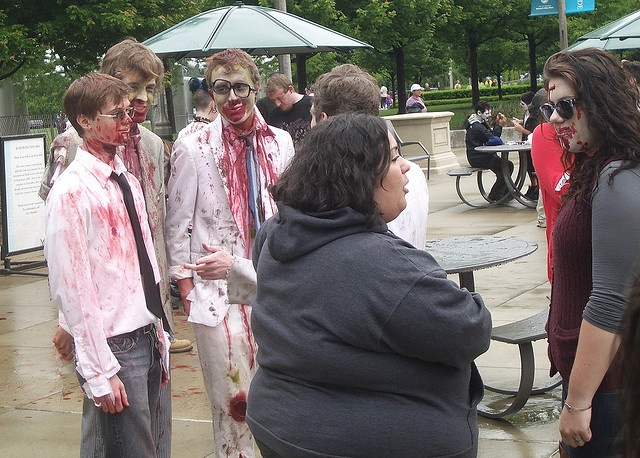Describe the objects in this image and their specific colors. I can see people in black and gray tones, people in black, gray, and maroon tones, people in black, lavender, gray, and brown tones, people in black, lavender, darkgray, brown, and pink tones, and people in black, gray, and darkgray tones in this image. 